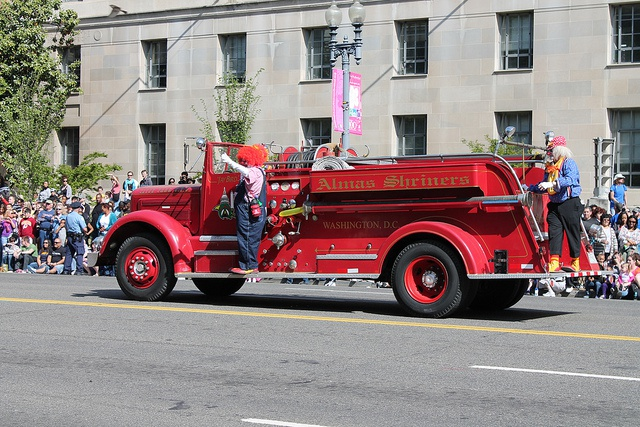Describe the objects in this image and their specific colors. I can see truck in tan, black, maroon, and brown tones, people in tan, black, lightgray, darkgray, and gray tones, people in tan, black, lightgray, and gray tones, people in tan, black, lavender, salmon, and darkblue tones, and people in tan, black, gray, and lightblue tones in this image. 